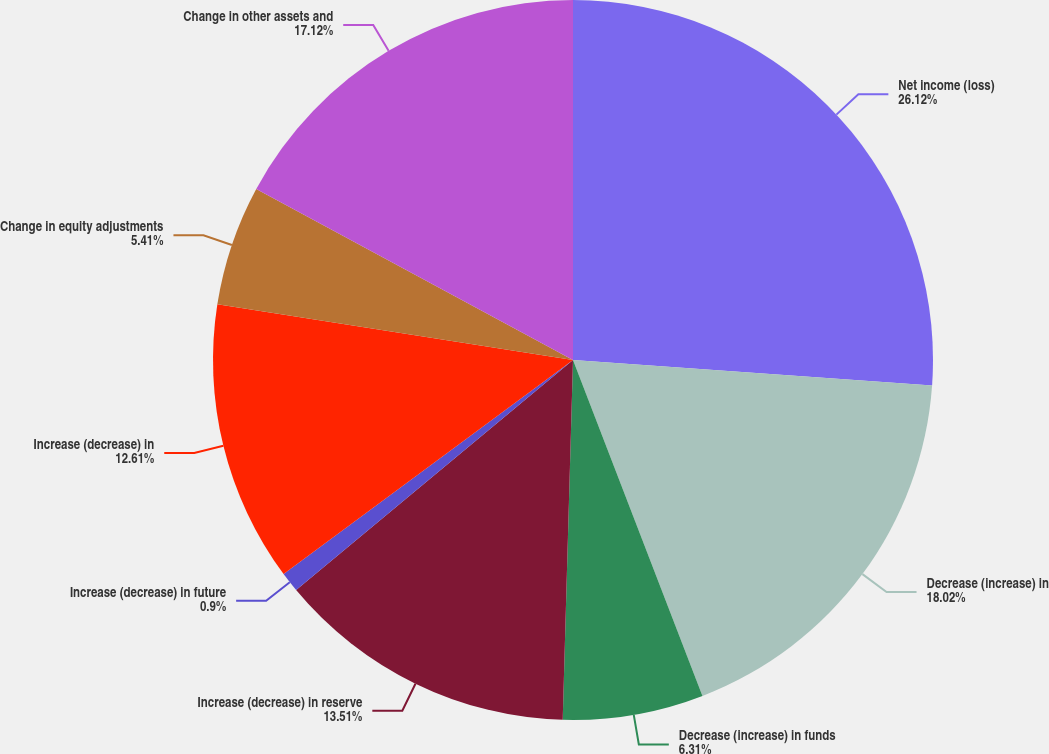<chart> <loc_0><loc_0><loc_500><loc_500><pie_chart><fcel>Net income (loss)<fcel>Decrease (increase) in<fcel>Decrease (increase) in funds<fcel>Increase (decrease) in reserve<fcel>Increase (decrease) in future<fcel>Increase (decrease) in<fcel>Change in equity adjustments<fcel>Change in other assets and<nl><fcel>26.13%<fcel>18.02%<fcel>6.31%<fcel>13.51%<fcel>0.9%<fcel>12.61%<fcel>5.41%<fcel>17.12%<nl></chart> 